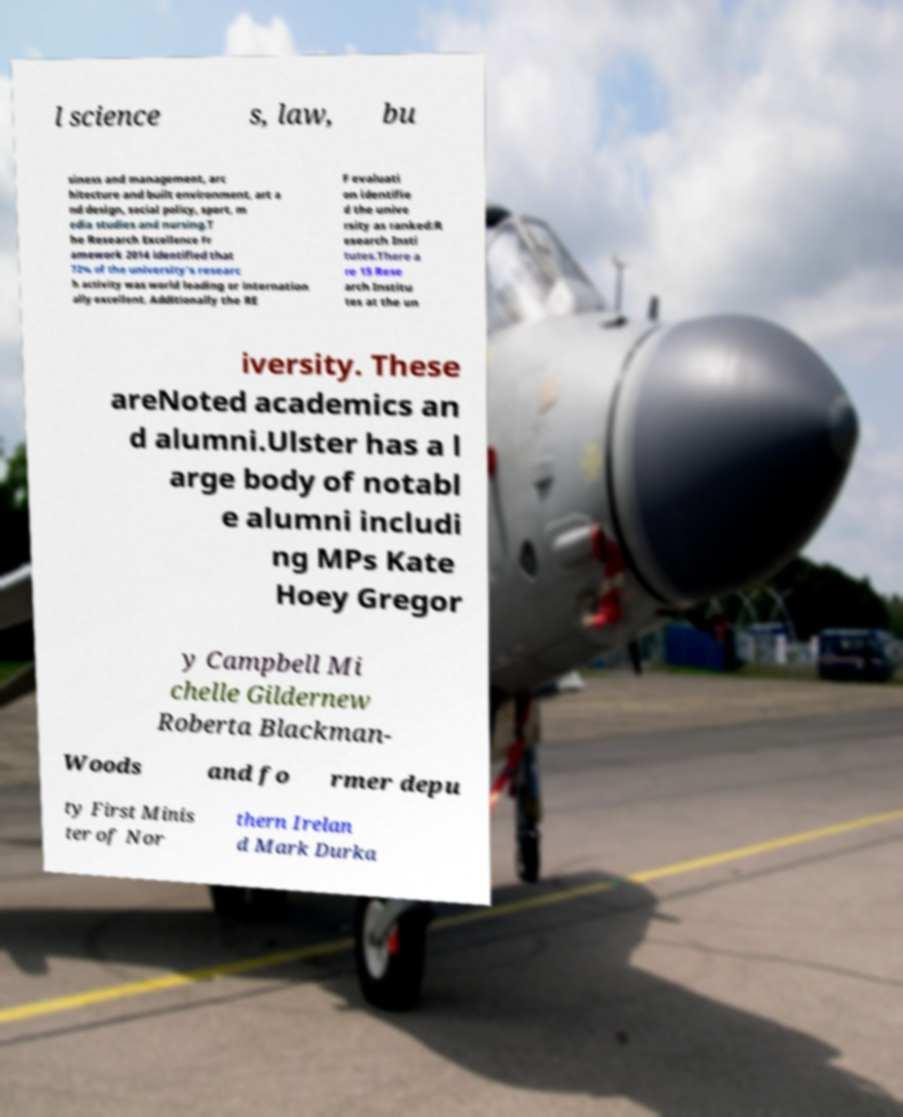There's text embedded in this image that I need extracted. Can you transcribe it verbatim? l science s, law, bu siness and management, arc hitecture and built environment, art a nd design, social policy, sport, m edia studies and nursing.T he Research Excellence Fr amework 2014 identified that 72% of the university's researc h activity was world leading or internation ally excellent. Additionally the RE F evaluati on identifie d the unive rsity as ranked:R esearch Insti tutes.There a re 15 Rese arch Institu tes at the un iversity. These areNoted academics an d alumni.Ulster has a l arge body of notabl e alumni includi ng MPs Kate Hoey Gregor y Campbell Mi chelle Gildernew Roberta Blackman- Woods and fo rmer depu ty First Minis ter of Nor thern Irelan d Mark Durka 